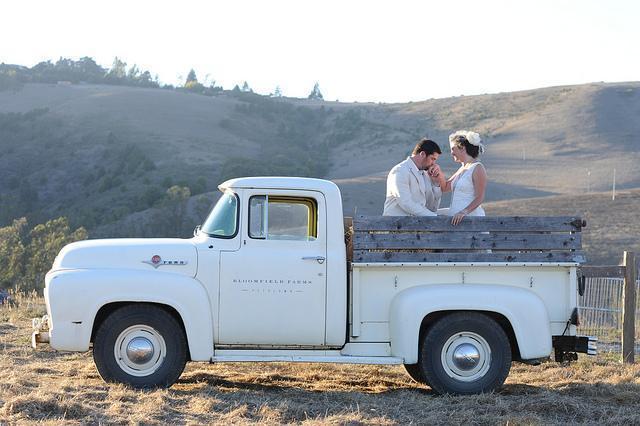How many people are there?
Give a very brief answer. 2. How many ceramic birds are there?
Give a very brief answer. 0. 